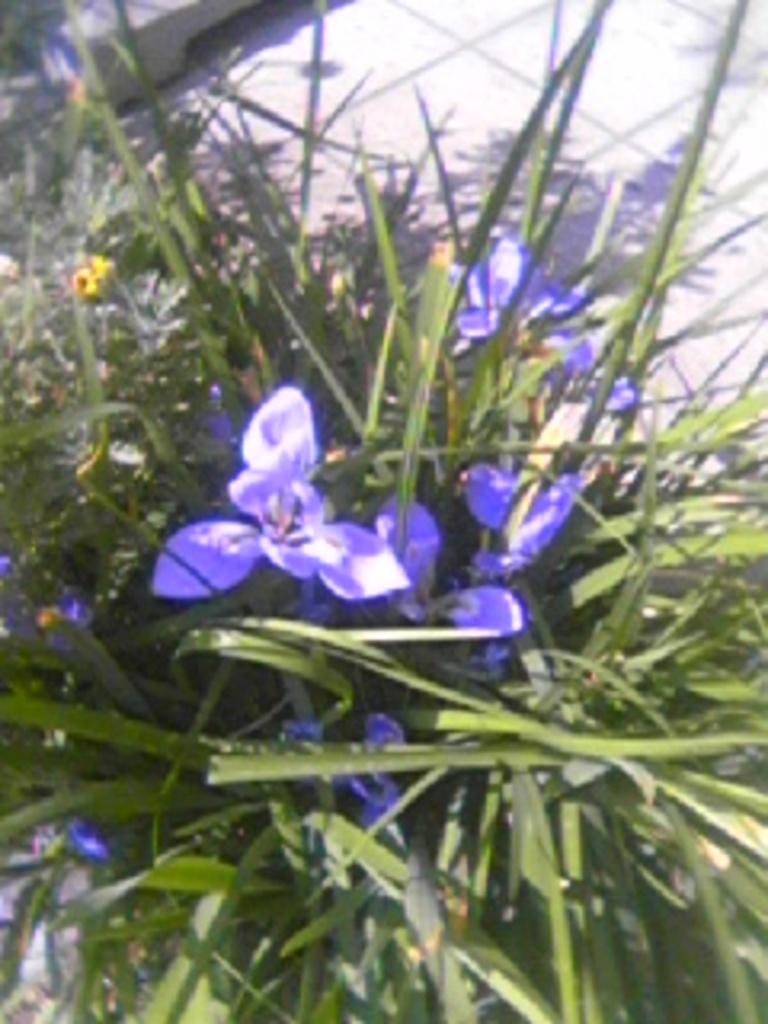What type of flowers can be seen in the image? There are purple color flowers in the image. What else is present in the image besides the flowers? There are leaves in the image. What part of the image shows the floor? The floor is visible at the top of the image. What year is depicted in the image? The image does not depict a specific year; it is a still image of flowers and leaves. What type of memory is being stored in the image? The image does not depict a memory being stored; it is a still image of flowers and leaves. 